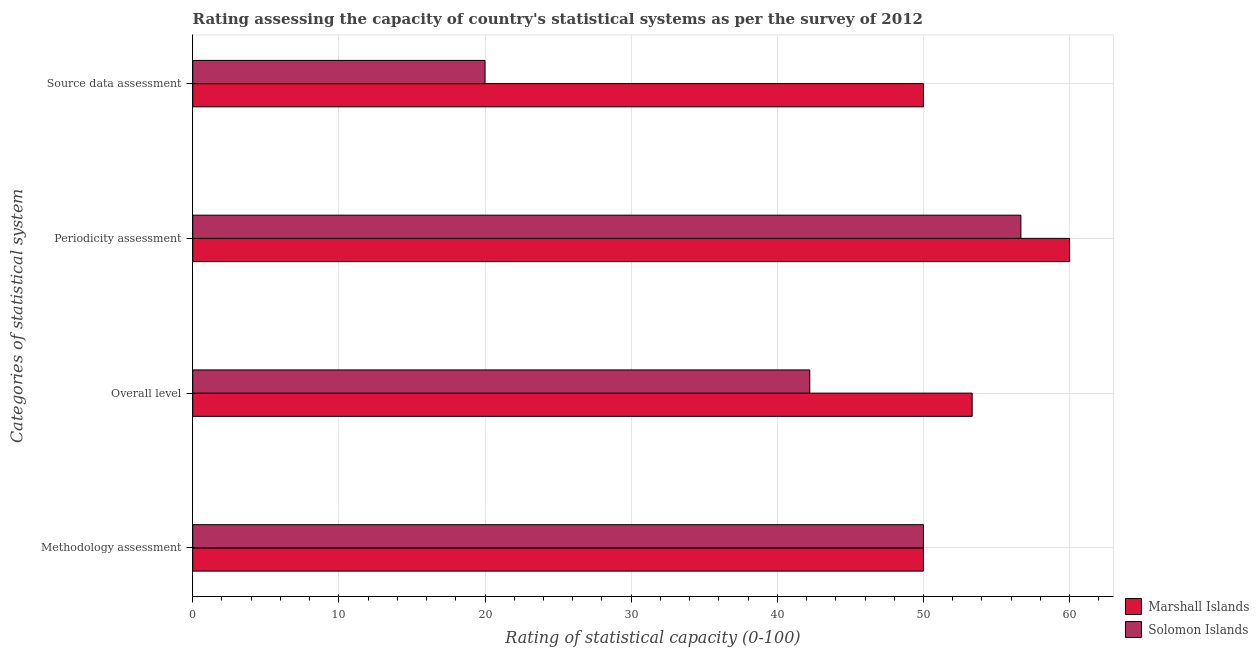How many different coloured bars are there?
Give a very brief answer. 2. How many groups of bars are there?
Provide a succinct answer. 4. Are the number of bars per tick equal to the number of legend labels?
Ensure brevity in your answer.  Yes. How many bars are there on the 3rd tick from the bottom?
Offer a terse response. 2. What is the label of the 2nd group of bars from the top?
Your response must be concise. Periodicity assessment. What is the periodicity assessment rating in Solomon Islands?
Your response must be concise. 56.67. Across all countries, what is the maximum methodology assessment rating?
Your response must be concise. 50. Across all countries, what is the minimum overall level rating?
Your answer should be very brief. 42.22. In which country was the overall level rating maximum?
Make the answer very short. Marshall Islands. In which country was the periodicity assessment rating minimum?
Offer a very short reply. Solomon Islands. What is the difference between the overall level rating in Solomon Islands and that in Marshall Islands?
Provide a succinct answer. -11.11. What is the difference between the overall level rating in Solomon Islands and the methodology assessment rating in Marshall Islands?
Keep it short and to the point. -7.78. What is the average overall level rating per country?
Ensure brevity in your answer.  47.78. What is the difference between the periodicity assessment rating and source data assessment rating in Solomon Islands?
Your answer should be compact. 36.67. What is the ratio of the periodicity assessment rating in Solomon Islands to that in Marshall Islands?
Offer a terse response. 0.94. Is the overall level rating in Marshall Islands less than that in Solomon Islands?
Make the answer very short. No. What is the difference between the highest and the second highest overall level rating?
Your answer should be very brief. 11.11. What is the difference between the highest and the lowest overall level rating?
Keep it short and to the point. 11.11. Is it the case that in every country, the sum of the periodicity assessment rating and source data assessment rating is greater than the sum of overall level rating and methodology assessment rating?
Ensure brevity in your answer.  No. What does the 2nd bar from the top in Methodology assessment represents?
Your response must be concise. Marshall Islands. What does the 1st bar from the bottom in Source data assessment represents?
Your response must be concise. Marshall Islands. Is it the case that in every country, the sum of the methodology assessment rating and overall level rating is greater than the periodicity assessment rating?
Your answer should be compact. Yes. How many bars are there?
Your response must be concise. 8. Are all the bars in the graph horizontal?
Offer a very short reply. Yes. How many countries are there in the graph?
Make the answer very short. 2. Where does the legend appear in the graph?
Your answer should be compact. Bottom right. How are the legend labels stacked?
Ensure brevity in your answer.  Vertical. What is the title of the graph?
Provide a short and direct response. Rating assessing the capacity of country's statistical systems as per the survey of 2012 . Does "East Asia (all income levels)" appear as one of the legend labels in the graph?
Your answer should be very brief. No. What is the label or title of the X-axis?
Offer a very short reply. Rating of statistical capacity (0-100). What is the label or title of the Y-axis?
Make the answer very short. Categories of statistical system. What is the Rating of statistical capacity (0-100) in Marshall Islands in Overall level?
Offer a very short reply. 53.33. What is the Rating of statistical capacity (0-100) in Solomon Islands in Overall level?
Your answer should be very brief. 42.22. What is the Rating of statistical capacity (0-100) in Solomon Islands in Periodicity assessment?
Make the answer very short. 56.67. What is the Rating of statistical capacity (0-100) of Marshall Islands in Source data assessment?
Your response must be concise. 50. What is the Rating of statistical capacity (0-100) of Solomon Islands in Source data assessment?
Offer a terse response. 20. Across all Categories of statistical system, what is the maximum Rating of statistical capacity (0-100) in Marshall Islands?
Offer a terse response. 60. Across all Categories of statistical system, what is the maximum Rating of statistical capacity (0-100) of Solomon Islands?
Offer a terse response. 56.67. What is the total Rating of statistical capacity (0-100) in Marshall Islands in the graph?
Keep it short and to the point. 213.33. What is the total Rating of statistical capacity (0-100) of Solomon Islands in the graph?
Make the answer very short. 168.89. What is the difference between the Rating of statistical capacity (0-100) in Marshall Islands in Methodology assessment and that in Overall level?
Provide a succinct answer. -3.33. What is the difference between the Rating of statistical capacity (0-100) in Solomon Islands in Methodology assessment and that in Overall level?
Your response must be concise. 7.78. What is the difference between the Rating of statistical capacity (0-100) of Marshall Islands in Methodology assessment and that in Periodicity assessment?
Offer a very short reply. -10. What is the difference between the Rating of statistical capacity (0-100) in Solomon Islands in Methodology assessment and that in Periodicity assessment?
Your answer should be compact. -6.67. What is the difference between the Rating of statistical capacity (0-100) of Marshall Islands in Overall level and that in Periodicity assessment?
Give a very brief answer. -6.67. What is the difference between the Rating of statistical capacity (0-100) in Solomon Islands in Overall level and that in Periodicity assessment?
Ensure brevity in your answer.  -14.44. What is the difference between the Rating of statistical capacity (0-100) of Solomon Islands in Overall level and that in Source data assessment?
Your answer should be very brief. 22.22. What is the difference between the Rating of statistical capacity (0-100) of Solomon Islands in Periodicity assessment and that in Source data assessment?
Provide a short and direct response. 36.67. What is the difference between the Rating of statistical capacity (0-100) of Marshall Islands in Methodology assessment and the Rating of statistical capacity (0-100) of Solomon Islands in Overall level?
Your response must be concise. 7.78. What is the difference between the Rating of statistical capacity (0-100) of Marshall Islands in Methodology assessment and the Rating of statistical capacity (0-100) of Solomon Islands in Periodicity assessment?
Provide a succinct answer. -6.67. What is the difference between the Rating of statistical capacity (0-100) in Marshall Islands in Methodology assessment and the Rating of statistical capacity (0-100) in Solomon Islands in Source data assessment?
Your answer should be very brief. 30. What is the difference between the Rating of statistical capacity (0-100) in Marshall Islands in Overall level and the Rating of statistical capacity (0-100) in Solomon Islands in Source data assessment?
Your answer should be very brief. 33.33. What is the difference between the Rating of statistical capacity (0-100) in Marshall Islands in Periodicity assessment and the Rating of statistical capacity (0-100) in Solomon Islands in Source data assessment?
Offer a very short reply. 40. What is the average Rating of statistical capacity (0-100) of Marshall Islands per Categories of statistical system?
Give a very brief answer. 53.33. What is the average Rating of statistical capacity (0-100) in Solomon Islands per Categories of statistical system?
Provide a succinct answer. 42.22. What is the difference between the Rating of statistical capacity (0-100) in Marshall Islands and Rating of statistical capacity (0-100) in Solomon Islands in Methodology assessment?
Keep it short and to the point. 0. What is the difference between the Rating of statistical capacity (0-100) in Marshall Islands and Rating of statistical capacity (0-100) in Solomon Islands in Overall level?
Provide a succinct answer. 11.11. What is the difference between the Rating of statistical capacity (0-100) in Marshall Islands and Rating of statistical capacity (0-100) in Solomon Islands in Periodicity assessment?
Give a very brief answer. 3.33. What is the difference between the Rating of statistical capacity (0-100) in Marshall Islands and Rating of statistical capacity (0-100) in Solomon Islands in Source data assessment?
Your answer should be compact. 30. What is the ratio of the Rating of statistical capacity (0-100) in Marshall Islands in Methodology assessment to that in Overall level?
Ensure brevity in your answer.  0.94. What is the ratio of the Rating of statistical capacity (0-100) of Solomon Islands in Methodology assessment to that in Overall level?
Your response must be concise. 1.18. What is the ratio of the Rating of statistical capacity (0-100) of Marshall Islands in Methodology assessment to that in Periodicity assessment?
Offer a very short reply. 0.83. What is the ratio of the Rating of statistical capacity (0-100) in Solomon Islands in Methodology assessment to that in Periodicity assessment?
Your answer should be compact. 0.88. What is the ratio of the Rating of statistical capacity (0-100) of Marshall Islands in Methodology assessment to that in Source data assessment?
Provide a succinct answer. 1. What is the ratio of the Rating of statistical capacity (0-100) of Solomon Islands in Methodology assessment to that in Source data assessment?
Offer a very short reply. 2.5. What is the ratio of the Rating of statistical capacity (0-100) in Solomon Islands in Overall level to that in Periodicity assessment?
Provide a succinct answer. 0.75. What is the ratio of the Rating of statistical capacity (0-100) of Marshall Islands in Overall level to that in Source data assessment?
Your answer should be compact. 1.07. What is the ratio of the Rating of statistical capacity (0-100) of Solomon Islands in Overall level to that in Source data assessment?
Keep it short and to the point. 2.11. What is the ratio of the Rating of statistical capacity (0-100) of Solomon Islands in Periodicity assessment to that in Source data assessment?
Give a very brief answer. 2.83. What is the difference between the highest and the second highest Rating of statistical capacity (0-100) of Solomon Islands?
Offer a very short reply. 6.67. What is the difference between the highest and the lowest Rating of statistical capacity (0-100) of Marshall Islands?
Offer a very short reply. 10. What is the difference between the highest and the lowest Rating of statistical capacity (0-100) of Solomon Islands?
Provide a succinct answer. 36.67. 